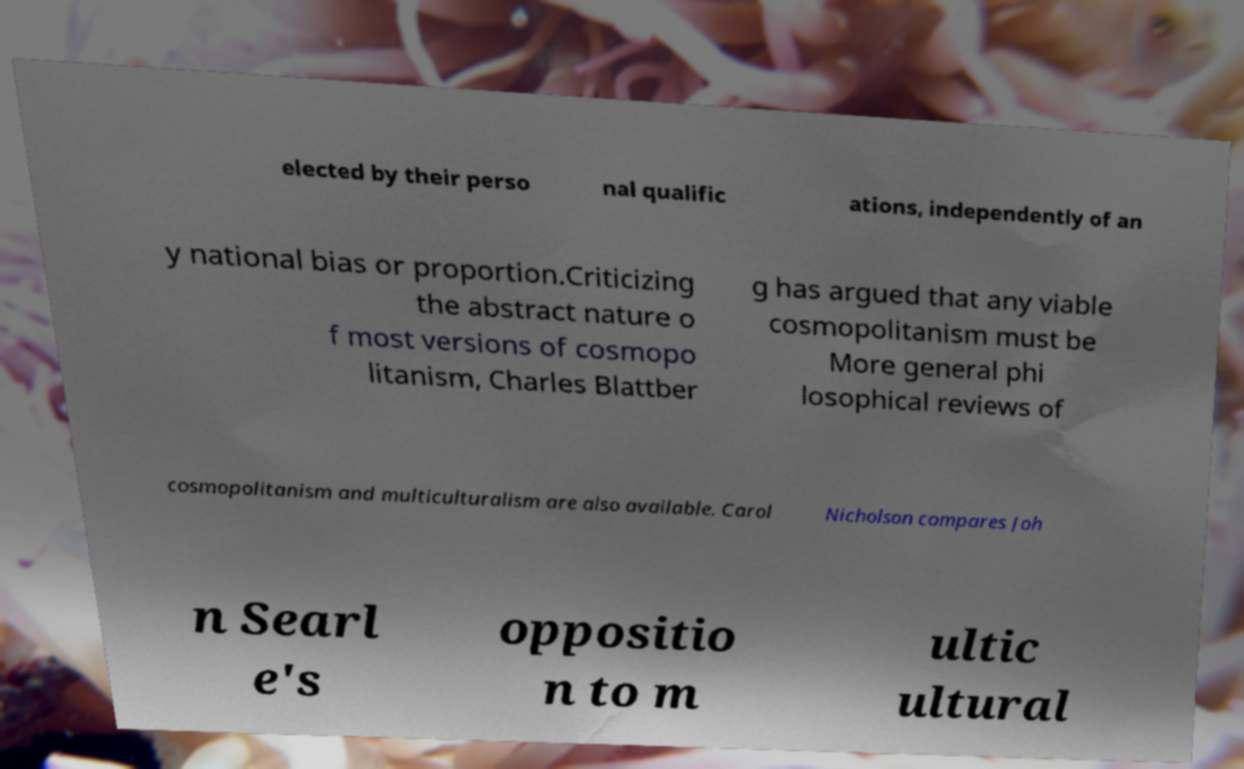Please identify and transcribe the text found in this image. elected by their perso nal qualific ations, independently of an y national bias or proportion.Criticizing the abstract nature o f most versions of cosmopo litanism, Charles Blattber g has argued that any viable cosmopolitanism must be More general phi losophical reviews of cosmopolitanism and multiculturalism are also available. Carol Nicholson compares Joh n Searl e's oppositio n to m ultic ultural 